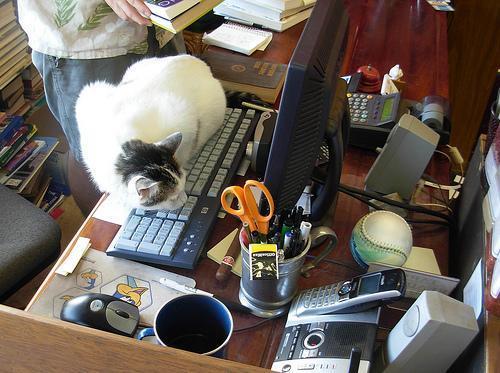How many calculators can be seen?
Give a very brief answer. 1. How many cats are pictured?
Give a very brief answer. 1. How many people are in the scene?
Give a very brief answer. 1. 